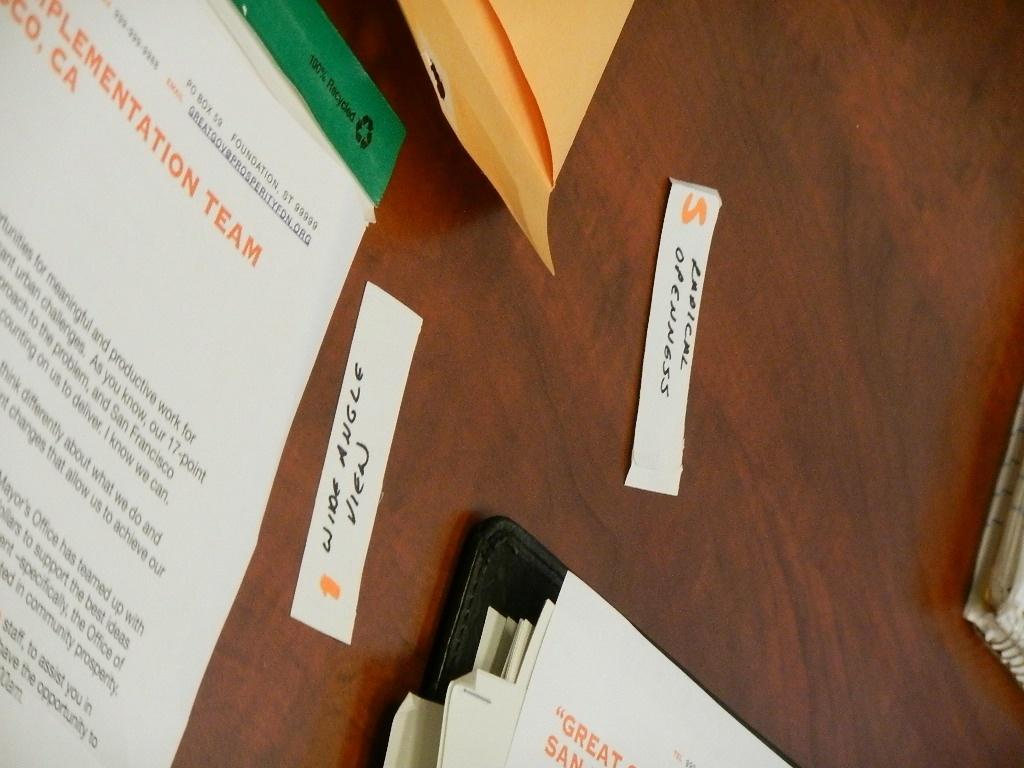Provide a one-sentence caption for the provided image. A table showing a few documents for an implementation team. 